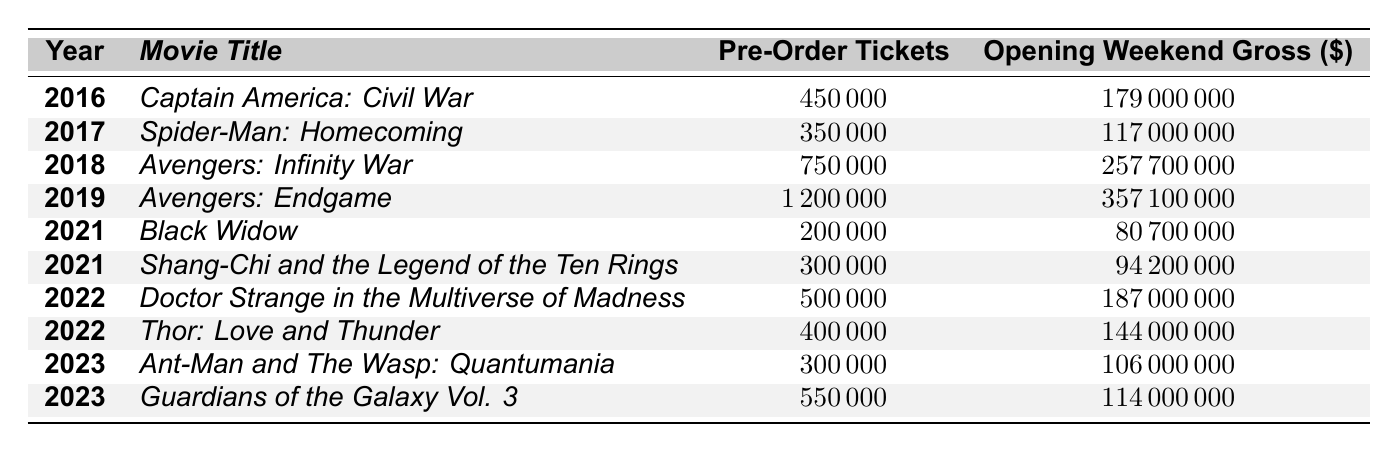What movie had the highest pre-order ticket sales? In the table, "Avengers: Endgame" in 2019 shows 1,200,000 pre-order tickets sold, which is the highest among all listed movies.
Answer: Avengers: Endgame What was the opening weekend gross for "Thor: Love and Thunder"? The table lists the opening weekend gross for "Thor: Love and Thunder" as $144,000,000.
Answer: $144,000,000 How many pre-order tickets were sold for "Doctor Strange in the Multiverse of Madness"? The table indicates that "Doctor Strange in the Multiverse of Madness" had 500,000 pre-order tickets sold.
Answer: 500,000 What is the total number of pre-order tickets sold across all movies listed from 2016 to 2023? Adding the pre-order ticket numbers: 450,000 + 350,000 + 750,000 + 1,200,000 + 200,000 + 300,000 + 500,000 + 400,000 + 300,000 + 550,000 = 4,950,000.
Answer: 4,950,000 Did "Black Widow" have a higher opening weekend gross than "Spider-Man: Homecoming"? "Black Widow" had an opening weekend gross of $80,700,000, and "Spider-Man: Homecoming" had $117,000,000, so "Black Widow" had a lower gross than "Spider-Man: Homecoming."
Answer: No What was the average pre-order tickets sold for MCU movies in 2021? There are two movies from 2021: "Black Widow" with 200,000 pre-order tickets and "Shang-Chi and the Legend of the Ten Rings" with 300,000. The average is (200,000 + 300,000) / 2 = 250,000.
Answer: 250,000 Which movie had the greatest difference between pre-order tickets sold and opening weekend gross? The calculations show: "Avengers: Endgame" (1,200,000 - 357,100,000), "Avengers: Infinity War" (750,000 - 257,700,000), etc. The maximum difference is for "Avengers: Endgame" and is calculated as follows: 357,100,000 - 1,200,000 = 355,900,000, which is the highest.
Answer: Avengers: Endgame How many movies had more than 500,000 pre-order tickets, and what were their titles? The movies with more than 500,000 pre-order tickets are "Avengers: Infinity War" (750,000) and "Avengers: Endgame" (1,200,000). Therefore, 2 movies had more than 500,000 pre-order tickets.
Answer: 2 movies: Avengers: Infinity War, Avengers: Endgame 